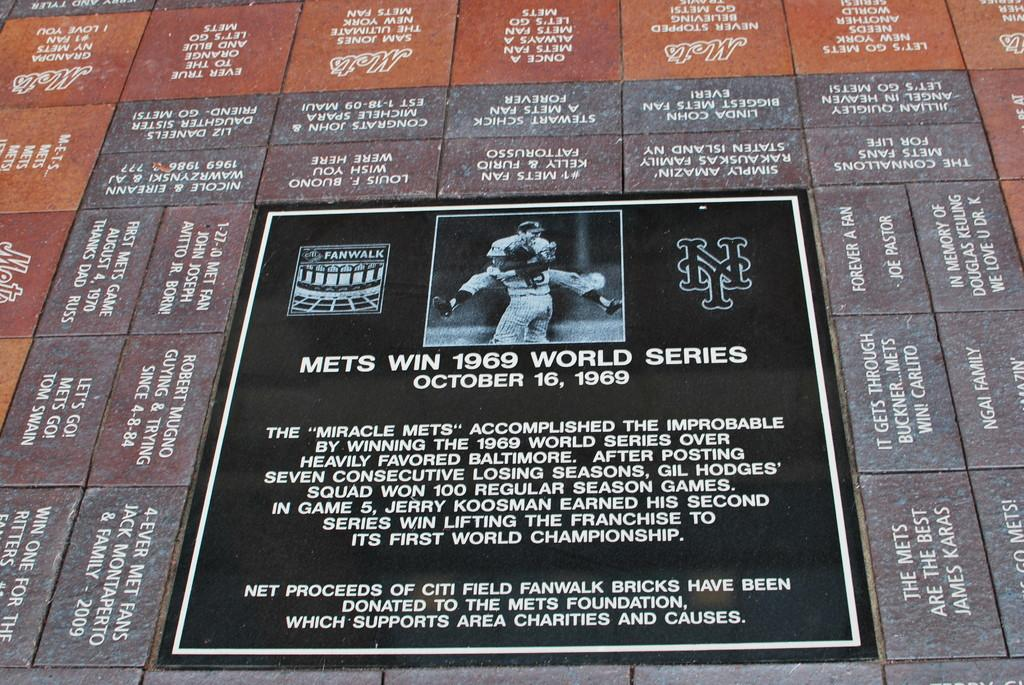<image>
Write a terse but informative summary of the picture. A plaque honoring the Mets 1969 world series win. 